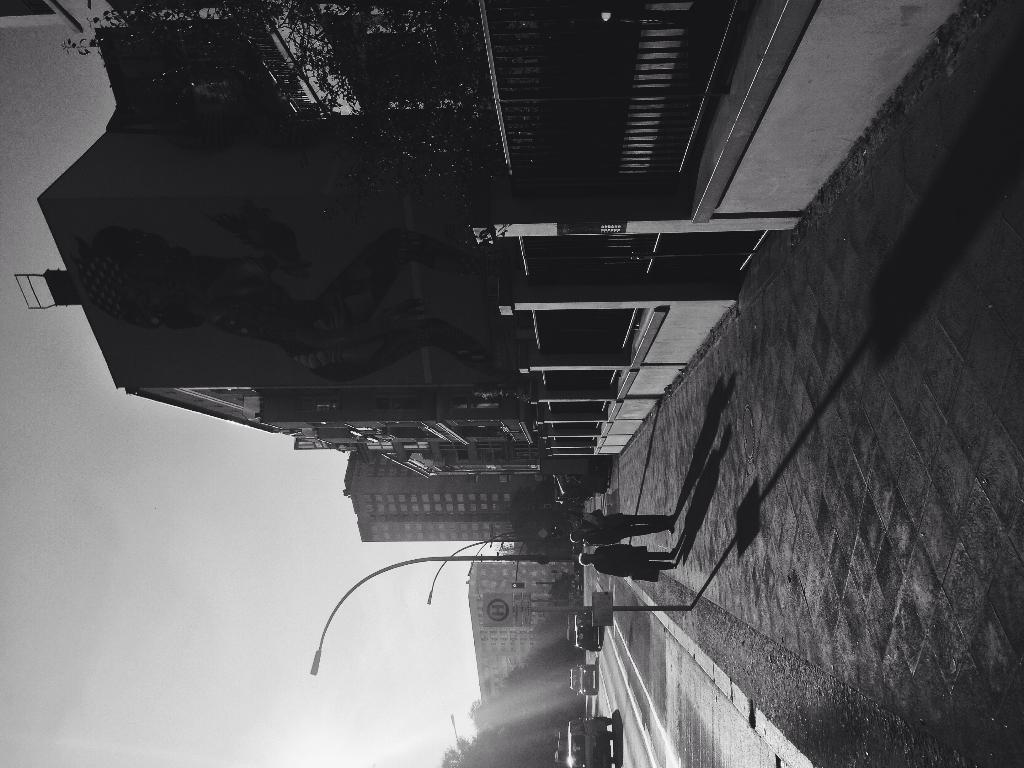Could you give a brief overview of what you see in this image? This is a black and white image. I can see two people standing. These are the streetlights. I can see the buildings with windows. This looks like a tree. I think this is the gate. I can see few vehicles on the road. 